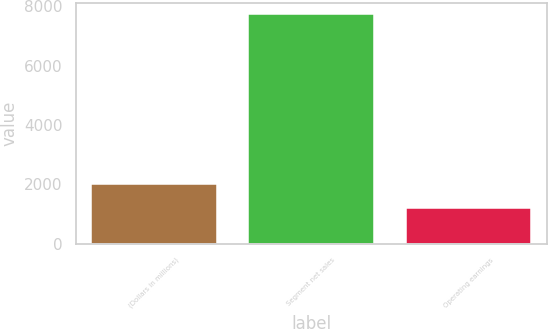Convert chart to OTSL. <chart><loc_0><loc_0><loc_500><loc_500><bar_chart><fcel>(Dollars in millions)<fcel>Segment net sales<fcel>Operating earnings<nl><fcel>2007<fcel>7729<fcel>1213<nl></chart> 